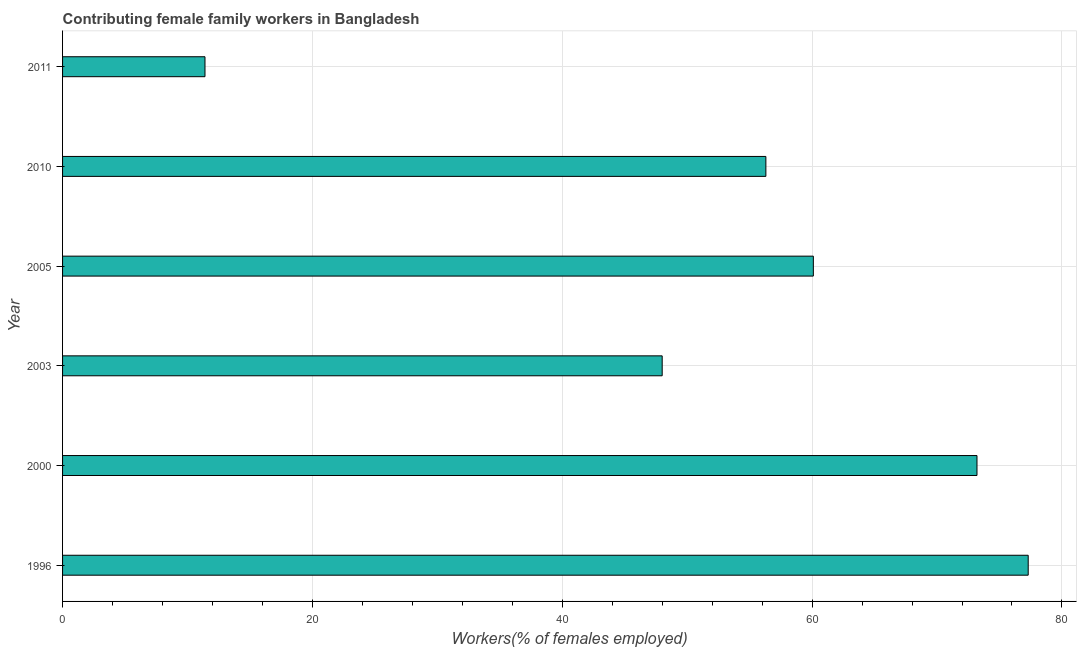Does the graph contain any zero values?
Provide a short and direct response. No. Does the graph contain grids?
Your response must be concise. Yes. What is the title of the graph?
Your answer should be very brief. Contributing female family workers in Bangladesh. What is the label or title of the X-axis?
Your response must be concise. Workers(% of females employed). What is the label or title of the Y-axis?
Provide a succinct answer. Year. What is the contributing female family workers in 1996?
Offer a terse response. 77.3. Across all years, what is the maximum contributing female family workers?
Keep it short and to the point. 77.3. Across all years, what is the minimum contributing female family workers?
Offer a very short reply. 11.4. In which year was the contributing female family workers minimum?
Make the answer very short. 2011. What is the sum of the contributing female family workers?
Keep it short and to the point. 326.3. What is the average contributing female family workers per year?
Your response must be concise. 54.38. What is the median contributing female family workers?
Make the answer very short. 58.2. Do a majority of the years between 2000 and 2011 (inclusive) have contributing female family workers greater than 72 %?
Keep it short and to the point. No. What is the ratio of the contributing female family workers in 2003 to that in 2005?
Offer a terse response. 0.8. Is the contributing female family workers in 1996 less than that in 2000?
Your answer should be very brief. No. Is the difference between the contributing female family workers in 1996 and 2010 greater than the difference between any two years?
Offer a very short reply. No. Is the sum of the contributing female family workers in 2003 and 2010 greater than the maximum contributing female family workers across all years?
Provide a succinct answer. Yes. What is the difference between the highest and the lowest contributing female family workers?
Provide a succinct answer. 65.9. How many bars are there?
Provide a short and direct response. 6. How many years are there in the graph?
Offer a terse response. 6. What is the difference between two consecutive major ticks on the X-axis?
Your answer should be compact. 20. Are the values on the major ticks of X-axis written in scientific E-notation?
Ensure brevity in your answer.  No. What is the Workers(% of females employed) in 1996?
Provide a short and direct response. 77.3. What is the Workers(% of females employed) of 2000?
Ensure brevity in your answer.  73.2. What is the Workers(% of females employed) in 2003?
Your response must be concise. 48. What is the Workers(% of females employed) of 2005?
Offer a very short reply. 60.1. What is the Workers(% of females employed) in 2010?
Make the answer very short. 56.3. What is the Workers(% of females employed) of 2011?
Your answer should be very brief. 11.4. What is the difference between the Workers(% of females employed) in 1996 and 2000?
Your response must be concise. 4.1. What is the difference between the Workers(% of females employed) in 1996 and 2003?
Keep it short and to the point. 29.3. What is the difference between the Workers(% of females employed) in 1996 and 2011?
Give a very brief answer. 65.9. What is the difference between the Workers(% of females employed) in 2000 and 2003?
Your answer should be compact. 25.2. What is the difference between the Workers(% of females employed) in 2000 and 2010?
Offer a terse response. 16.9. What is the difference between the Workers(% of females employed) in 2000 and 2011?
Give a very brief answer. 61.8. What is the difference between the Workers(% of females employed) in 2003 and 2011?
Ensure brevity in your answer.  36.6. What is the difference between the Workers(% of females employed) in 2005 and 2010?
Give a very brief answer. 3.8. What is the difference between the Workers(% of females employed) in 2005 and 2011?
Ensure brevity in your answer.  48.7. What is the difference between the Workers(% of females employed) in 2010 and 2011?
Your answer should be very brief. 44.9. What is the ratio of the Workers(% of females employed) in 1996 to that in 2000?
Keep it short and to the point. 1.06. What is the ratio of the Workers(% of females employed) in 1996 to that in 2003?
Offer a very short reply. 1.61. What is the ratio of the Workers(% of females employed) in 1996 to that in 2005?
Ensure brevity in your answer.  1.29. What is the ratio of the Workers(% of females employed) in 1996 to that in 2010?
Offer a very short reply. 1.37. What is the ratio of the Workers(% of females employed) in 1996 to that in 2011?
Provide a short and direct response. 6.78. What is the ratio of the Workers(% of females employed) in 2000 to that in 2003?
Provide a succinct answer. 1.52. What is the ratio of the Workers(% of females employed) in 2000 to that in 2005?
Make the answer very short. 1.22. What is the ratio of the Workers(% of females employed) in 2000 to that in 2010?
Offer a terse response. 1.3. What is the ratio of the Workers(% of females employed) in 2000 to that in 2011?
Provide a succinct answer. 6.42. What is the ratio of the Workers(% of females employed) in 2003 to that in 2005?
Keep it short and to the point. 0.8. What is the ratio of the Workers(% of females employed) in 2003 to that in 2010?
Keep it short and to the point. 0.85. What is the ratio of the Workers(% of females employed) in 2003 to that in 2011?
Your response must be concise. 4.21. What is the ratio of the Workers(% of females employed) in 2005 to that in 2010?
Give a very brief answer. 1.07. What is the ratio of the Workers(% of females employed) in 2005 to that in 2011?
Provide a succinct answer. 5.27. What is the ratio of the Workers(% of females employed) in 2010 to that in 2011?
Give a very brief answer. 4.94. 